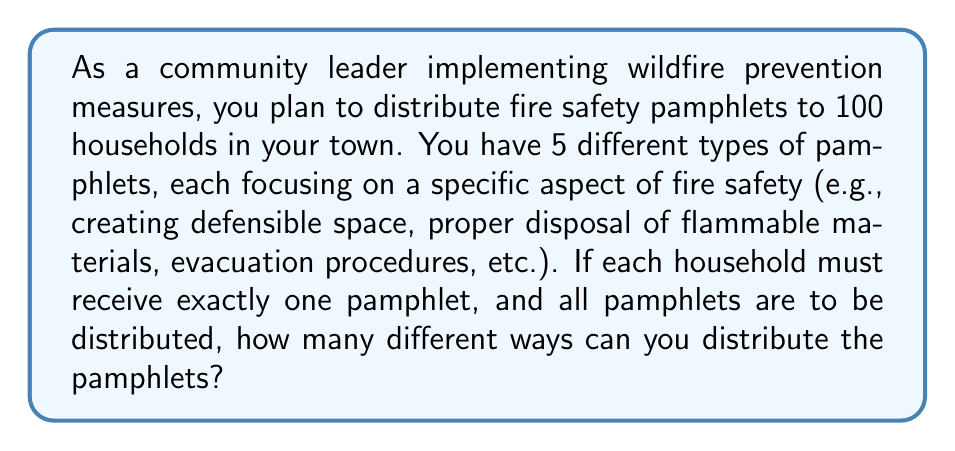Solve this math problem. To solve this problem, we need to use the concept of permutations with repetition. Here's a step-by-step explanation:

1) We have 100 households (positions to fill) and 5 types of pamphlets (choices for each position).

2) For each household, we have 5 choices of pamphlets to give.

3) The choices for each household are independent of the choices for other households.

4) The order of distribution matters (e.g., giving pamphlet A to household 1 and pamphlet B to household 2 is different from giving pamphlet B to household 1 and pamphlet A to household 2).

5) We can use pamphlets multiple times (repetition is allowed).

Given these conditions, we can use the formula for permutations with repetition:

$$ \text{Number of ways} = n^r $$

Where:
$n$ = number of types of objects (in this case, types of pamphlets)
$r$ = number of positions to fill (in this case, number of households)

Plugging in our values:

$$ \text{Number of ways} = 5^{100} $$

This results in an extremely large number, which can be expressed in scientific notation as approximately:

$$ 7.88860905221 \times 10^{69} $$
Answer: $5^{100}$ or approximately $7.89 \times 10^{69}$ 